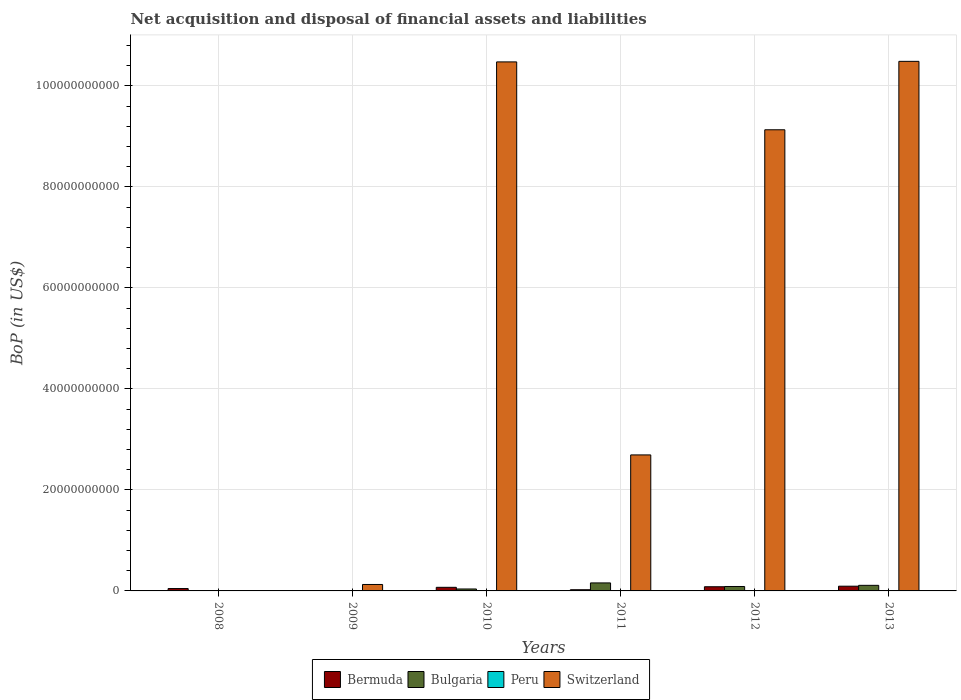How many different coloured bars are there?
Your answer should be very brief. 3. Are the number of bars per tick equal to the number of legend labels?
Your response must be concise. No. How many bars are there on the 2nd tick from the right?
Your answer should be compact. 3. What is the label of the 3rd group of bars from the left?
Keep it short and to the point. 2010. In how many cases, is the number of bars for a given year not equal to the number of legend labels?
Keep it short and to the point. 6. What is the Balance of Payments in Bulgaria in 2008?
Offer a very short reply. 0. Across all years, what is the maximum Balance of Payments in Bermuda?
Provide a succinct answer. 9.35e+08. In which year was the Balance of Payments in Switzerland maximum?
Offer a very short reply. 2013. What is the total Balance of Payments in Bulgaria in the graph?
Provide a succinct answer. 3.96e+09. What is the difference between the Balance of Payments in Bulgaria in 2012 and that in 2013?
Ensure brevity in your answer.  -2.30e+08. What is the difference between the Balance of Payments in Peru in 2008 and the Balance of Payments in Switzerland in 2011?
Offer a terse response. -2.69e+1. What is the average Balance of Payments in Bermuda per year?
Provide a short and direct response. 5.31e+08. In the year 2012, what is the difference between the Balance of Payments in Bulgaria and Balance of Payments in Bermuda?
Provide a short and direct response. 4.86e+07. Is the difference between the Balance of Payments in Bulgaria in 2011 and 2013 greater than the difference between the Balance of Payments in Bermuda in 2011 and 2013?
Offer a very short reply. Yes. What is the difference between the highest and the second highest Balance of Payments in Bermuda?
Your answer should be compact. 1.07e+08. What is the difference between the highest and the lowest Balance of Payments in Bulgaria?
Keep it short and to the point. 1.59e+09. In how many years, is the Balance of Payments in Peru greater than the average Balance of Payments in Peru taken over all years?
Give a very brief answer. 0. Are all the bars in the graph horizontal?
Provide a short and direct response. No. What is the difference between two consecutive major ticks on the Y-axis?
Provide a succinct answer. 2.00e+1. Does the graph contain any zero values?
Give a very brief answer. Yes. Does the graph contain grids?
Keep it short and to the point. Yes. Where does the legend appear in the graph?
Your answer should be compact. Bottom center. What is the title of the graph?
Keep it short and to the point. Net acquisition and disposal of financial assets and liabilities. Does "Argentina" appear as one of the legend labels in the graph?
Give a very brief answer. No. What is the label or title of the Y-axis?
Ensure brevity in your answer.  BoP (in US$). What is the BoP (in US$) in Bermuda in 2008?
Your answer should be compact. 4.69e+08. What is the BoP (in US$) in Peru in 2008?
Provide a short and direct response. 0. What is the BoP (in US$) in Bermuda in 2009?
Your answer should be compact. 0. What is the BoP (in US$) of Peru in 2009?
Your answer should be very brief. 0. What is the BoP (in US$) of Switzerland in 2009?
Make the answer very short. 1.28e+09. What is the BoP (in US$) in Bermuda in 2010?
Your answer should be compact. 7.14e+08. What is the BoP (in US$) in Bulgaria in 2010?
Give a very brief answer. 3.84e+08. What is the BoP (in US$) of Switzerland in 2010?
Provide a short and direct response. 1.05e+11. What is the BoP (in US$) in Bermuda in 2011?
Give a very brief answer. 2.37e+08. What is the BoP (in US$) of Bulgaria in 2011?
Give a very brief answer. 1.59e+09. What is the BoP (in US$) in Peru in 2011?
Keep it short and to the point. 0. What is the BoP (in US$) of Switzerland in 2011?
Provide a succinct answer. 2.69e+1. What is the BoP (in US$) in Bermuda in 2012?
Offer a very short reply. 8.28e+08. What is the BoP (in US$) in Bulgaria in 2012?
Keep it short and to the point. 8.77e+08. What is the BoP (in US$) of Switzerland in 2012?
Your answer should be compact. 9.13e+1. What is the BoP (in US$) in Bermuda in 2013?
Give a very brief answer. 9.35e+08. What is the BoP (in US$) of Bulgaria in 2013?
Make the answer very short. 1.11e+09. What is the BoP (in US$) of Switzerland in 2013?
Make the answer very short. 1.05e+11. Across all years, what is the maximum BoP (in US$) in Bermuda?
Ensure brevity in your answer.  9.35e+08. Across all years, what is the maximum BoP (in US$) in Bulgaria?
Your response must be concise. 1.59e+09. Across all years, what is the maximum BoP (in US$) in Switzerland?
Make the answer very short. 1.05e+11. Across all years, what is the minimum BoP (in US$) of Bermuda?
Your answer should be compact. 0. What is the total BoP (in US$) of Bermuda in the graph?
Make the answer very short. 3.18e+09. What is the total BoP (in US$) of Bulgaria in the graph?
Your answer should be very brief. 3.96e+09. What is the total BoP (in US$) in Peru in the graph?
Offer a terse response. 0. What is the total BoP (in US$) of Switzerland in the graph?
Ensure brevity in your answer.  3.29e+11. What is the difference between the BoP (in US$) of Bermuda in 2008 and that in 2010?
Give a very brief answer. -2.45e+08. What is the difference between the BoP (in US$) of Bermuda in 2008 and that in 2011?
Your answer should be very brief. 2.32e+08. What is the difference between the BoP (in US$) in Bermuda in 2008 and that in 2012?
Keep it short and to the point. -3.59e+08. What is the difference between the BoP (in US$) of Bermuda in 2008 and that in 2013?
Your answer should be compact. -4.66e+08. What is the difference between the BoP (in US$) of Switzerland in 2009 and that in 2010?
Provide a short and direct response. -1.03e+11. What is the difference between the BoP (in US$) of Switzerland in 2009 and that in 2011?
Provide a short and direct response. -2.57e+1. What is the difference between the BoP (in US$) of Switzerland in 2009 and that in 2012?
Ensure brevity in your answer.  -9.00e+1. What is the difference between the BoP (in US$) of Switzerland in 2009 and that in 2013?
Provide a short and direct response. -1.04e+11. What is the difference between the BoP (in US$) in Bermuda in 2010 and that in 2011?
Make the answer very short. 4.77e+08. What is the difference between the BoP (in US$) in Bulgaria in 2010 and that in 2011?
Your response must be concise. -1.20e+09. What is the difference between the BoP (in US$) in Switzerland in 2010 and that in 2011?
Provide a succinct answer. 7.78e+1. What is the difference between the BoP (in US$) of Bermuda in 2010 and that in 2012?
Provide a short and direct response. -1.14e+08. What is the difference between the BoP (in US$) of Bulgaria in 2010 and that in 2012?
Make the answer very short. -4.93e+08. What is the difference between the BoP (in US$) of Switzerland in 2010 and that in 2012?
Keep it short and to the point. 1.34e+1. What is the difference between the BoP (in US$) in Bermuda in 2010 and that in 2013?
Offer a terse response. -2.21e+08. What is the difference between the BoP (in US$) of Bulgaria in 2010 and that in 2013?
Keep it short and to the point. -7.23e+08. What is the difference between the BoP (in US$) of Switzerland in 2010 and that in 2013?
Keep it short and to the point. -1.09e+08. What is the difference between the BoP (in US$) of Bermuda in 2011 and that in 2012?
Your answer should be compact. -5.91e+08. What is the difference between the BoP (in US$) in Bulgaria in 2011 and that in 2012?
Provide a short and direct response. 7.10e+08. What is the difference between the BoP (in US$) of Switzerland in 2011 and that in 2012?
Offer a terse response. -6.44e+1. What is the difference between the BoP (in US$) of Bermuda in 2011 and that in 2013?
Ensure brevity in your answer.  -6.98e+08. What is the difference between the BoP (in US$) in Bulgaria in 2011 and that in 2013?
Offer a very short reply. 4.80e+08. What is the difference between the BoP (in US$) of Switzerland in 2011 and that in 2013?
Your answer should be compact. -7.79e+1. What is the difference between the BoP (in US$) in Bermuda in 2012 and that in 2013?
Make the answer very short. -1.07e+08. What is the difference between the BoP (in US$) in Bulgaria in 2012 and that in 2013?
Provide a succinct answer. -2.30e+08. What is the difference between the BoP (in US$) of Switzerland in 2012 and that in 2013?
Keep it short and to the point. -1.35e+1. What is the difference between the BoP (in US$) in Bermuda in 2008 and the BoP (in US$) in Switzerland in 2009?
Your answer should be compact. -8.06e+08. What is the difference between the BoP (in US$) in Bermuda in 2008 and the BoP (in US$) in Bulgaria in 2010?
Make the answer very short. 8.53e+07. What is the difference between the BoP (in US$) of Bermuda in 2008 and the BoP (in US$) of Switzerland in 2010?
Ensure brevity in your answer.  -1.04e+11. What is the difference between the BoP (in US$) of Bermuda in 2008 and the BoP (in US$) of Bulgaria in 2011?
Give a very brief answer. -1.12e+09. What is the difference between the BoP (in US$) of Bermuda in 2008 and the BoP (in US$) of Switzerland in 2011?
Your answer should be very brief. -2.65e+1. What is the difference between the BoP (in US$) in Bermuda in 2008 and the BoP (in US$) in Bulgaria in 2012?
Provide a succinct answer. -4.07e+08. What is the difference between the BoP (in US$) in Bermuda in 2008 and the BoP (in US$) in Switzerland in 2012?
Offer a very short reply. -9.09e+1. What is the difference between the BoP (in US$) of Bermuda in 2008 and the BoP (in US$) of Bulgaria in 2013?
Provide a short and direct response. -6.37e+08. What is the difference between the BoP (in US$) of Bermuda in 2008 and the BoP (in US$) of Switzerland in 2013?
Make the answer very short. -1.04e+11. What is the difference between the BoP (in US$) in Bermuda in 2010 and the BoP (in US$) in Bulgaria in 2011?
Provide a short and direct response. -8.73e+08. What is the difference between the BoP (in US$) in Bermuda in 2010 and the BoP (in US$) in Switzerland in 2011?
Offer a terse response. -2.62e+1. What is the difference between the BoP (in US$) in Bulgaria in 2010 and the BoP (in US$) in Switzerland in 2011?
Give a very brief answer. -2.65e+1. What is the difference between the BoP (in US$) in Bermuda in 2010 and the BoP (in US$) in Bulgaria in 2012?
Your answer should be very brief. -1.63e+08. What is the difference between the BoP (in US$) in Bermuda in 2010 and the BoP (in US$) in Switzerland in 2012?
Offer a terse response. -9.06e+1. What is the difference between the BoP (in US$) in Bulgaria in 2010 and the BoP (in US$) in Switzerland in 2012?
Keep it short and to the point. -9.09e+1. What is the difference between the BoP (in US$) of Bermuda in 2010 and the BoP (in US$) of Bulgaria in 2013?
Your response must be concise. -3.93e+08. What is the difference between the BoP (in US$) in Bermuda in 2010 and the BoP (in US$) in Switzerland in 2013?
Offer a terse response. -1.04e+11. What is the difference between the BoP (in US$) in Bulgaria in 2010 and the BoP (in US$) in Switzerland in 2013?
Give a very brief answer. -1.04e+11. What is the difference between the BoP (in US$) in Bermuda in 2011 and the BoP (in US$) in Bulgaria in 2012?
Your response must be concise. -6.39e+08. What is the difference between the BoP (in US$) of Bermuda in 2011 and the BoP (in US$) of Switzerland in 2012?
Provide a succinct answer. -9.11e+1. What is the difference between the BoP (in US$) of Bulgaria in 2011 and the BoP (in US$) of Switzerland in 2012?
Provide a short and direct response. -8.97e+1. What is the difference between the BoP (in US$) of Bermuda in 2011 and the BoP (in US$) of Bulgaria in 2013?
Provide a short and direct response. -8.69e+08. What is the difference between the BoP (in US$) in Bermuda in 2011 and the BoP (in US$) in Switzerland in 2013?
Make the answer very short. -1.05e+11. What is the difference between the BoP (in US$) in Bulgaria in 2011 and the BoP (in US$) in Switzerland in 2013?
Your answer should be very brief. -1.03e+11. What is the difference between the BoP (in US$) in Bermuda in 2012 and the BoP (in US$) in Bulgaria in 2013?
Offer a terse response. -2.79e+08. What is the difference between the BoP (in US$) in Bermuda in 2012 and the BoP (in US$) in Switzerland in 2013?
Keep it short and to the point. -1.04e+11. What is the difference between the BoP (in US$) of Bulgaria in 2012 and the BoP (in US$) of Switzerland in 2013?
Give a very brief answer. -1.04e+11. What is the average BoP (in US$) of Bermuda per year?
Offer a very short reply. 5.31e+08. What is the average BoP (in US$) in Bulgaria per year?
Make the answer very short. 6.59e+08. What is the average BoP (in US$) in Switzerland per year?
Provide a succinct answer. 5.49e+1. In the year 2010, what is the difference between the BoP (in US$) in Bermuda and BoP (in US$) in Bulgaria?
Your answer should be very brief. 3.30e+08. In the year 2010, what is the difference between the BoP (in US$) of Bermuda and BoP (in US$) of Switzerland?
Offer a terse response. -1.04e+11. In the year 2010, what is the difference between the BoP (in US$) in Bulgaria and BoP (in US$) in Switzerland?
Give a very brief answer. -1.04e+11. In the year 2011, what is the difference between the BoP (in US$) in Bermuda and BoP (in US$) in Bulgaria?
Keep it short and to the point. -1.35e+09. In the year 2011, what is the difference between the BoP (in US$) in Bermuda and BoP (in US$) in Switzerland?
Your answer should be very brief. -2.67e+1. In the year 2011, what is the difference between the BoP (in US$) of Bulgaria and BoP (in US$) of Switzerland?
Your response must be concise. -2.53e+1. In the year 2012, what is the difference between the BoP (in US$) in Bermuda and BoP (in US$) in Bulgaria?
Your response must be concise. -4.86e+07. In the year 2012, what is the difference between the BoP (in US$) of Bermuda and BoP (in US$) of Switzerland?
Offer a very short reply. -9.05e+1. In the year 2012, what is the difference between the BoP (in US$) in Bulgaria and BoP (in US$) in Switzerland?
Make the answer very short. -9.04e+1. In the year 2013, what is the difference between the BoP (in US$) in Bermuda and BoP (in US$) in Bulgaria?
Provide a succinct answer. -1.72e+08. In the year 2013, what is the difference between the BoP (in US$) in Bermuda and BoP (in US$) in Switzerland?
Provide a short and direct response. -1.04e+11. In the year 2013, what is the difference between the BoP (in US$) in Bulgaria and BoP (in US$) in Switzerland?
Provide a short and direct response. -1.04e+11. What is the ratio of the BoP (in US$) in Bermuda in 2008 to that in 2010?
Ensure brevity in your answer.  0.66. What is the ratio of the BoP (in US$) of Bermuda in 2008 to that in 2011?
Provide a succinct answer. 1.98. What is the ratio of the BoP (in US$) of Bermuda in 2008 to that in 2012?
Give a very brief answer. 0.57. What is the ratio of the BoP (in US$) in Bermuda in 2008 to that in 2013?
Your answer should be compact. 0.5. What is the ratio of the BoP (in US$) of Switzerland in 2009 to that in 2010?
Offer a terse response. 0.01. What is the ratio of the BoP (in US$) in Switzerland in 2009 to that in 2011?
Your response must be concise. 0.05. What is the ratio of the BoP (in US$) in Switzerland in 2009 to that in 2012?
Give a very brief answer. 0.01. What is the ratio of the BoP (in US$) in Switzerland in 2009 to that in 2013?
Keep it short and to the point. 0.01. What is the ratio of the BoP (in US$) in Bermuda in 2010 to that in 2011?
Keep it short and to the point. 3.01. What is the ratio of the BoP (in US$) in Bulgaria in 2010 to that in 2011?
Ensure brevity in your answer.  0.24. What is the ratio of the BoP (in US$) of Switzerland in 2010 to that in 2011?
Ensure brevity in your answer.  3.89. What is the ratio of the BoP (in US$) of Bermuda in 2010 to that in 2012?
Your answer should be very brief. 0.86. What is the ratio of the BoP (in US$) in Bulgaria in 2010 to that in 2012?
Provide a short and direct response. 0.44. What is the ratio of the BoP (in US$) in Switzerland in 2010 to that in 2012?
Provide a short and direct response. 1.15. What is the ratio of the BoP (in US$) of Bermuda in 2010 to that in 2013?
Provide a short and direct response. 0.76. What is the ratio of the BoP (in US$) of Bulgaria in 2010 to that in 2013?
Provide a short and direct response. 0.35. What is the ratio of the BoP (in US$) of Switzerland in 2010 to that in 2013?
Give a very brief answer. 1. What is the ratio of the BoP (in US$) of Bermuda in 2011 to that in 2012?
Make the answer very short. 0.29. What is the ratio of the BoP (in US$) in Bulgaria in 2011 to that in 2012?
Keep it short and to the point. 1.81. What is the ratio of the BoP (in US$) in Switzerland in 2011 to that in 2012?
Make the answer very short. 0.29. What is the ratio of the BoP (in US$) in Bermuda in 2011 to that in 2013?
Keep it short and to the point. 0.25. What is the ratio of the BoP (in US$) of Bulgaria in 2011 to that in 2013?
Offer a terse response. 1.43. What is the ratio of the BoP (in US$) in Switzerland in 2011 to that in 2013?
Keep it short and to the point. 0.26. What is the ratio of the BoP (in US$) of Bermuda in 2012 to that in 2013?
Your response must be concise. 0.89. What is the ratio of the BoP (in US$) of Bulgaria in 2012 to that in 2013?
Your answer should be compact. 0.79. What is the ratio of the BoP (in US$) of Switzerland in 2012 to that in 2013?
Make the answer very short. 0.87. What is the difference between the highest and the second highest BoP (in US$) in Bermuda?
Make the answer very short. 1.07e+08. What is the difference between the highest and the second highest BoP (in US$) in Bulgaria?
Offer a very short reply. 4.80e+08. What is the difference between the highest and the second highest BoP (in US$) in Switzerland?
Offer a very short reply. 1.09e+08. What is the difference between the highest and the lowest BoP (in US$) in Bermuda?
Your answer should be compact. 9.35e+08. What is the difference between the highest and the lowest BoP (in US$) in Bulgaria?
Your answer should be very brief. 1.59e+09. What is the difference between the highest and the lowest BoP (in US$) in Switzerland?
Your answer should be compact. 1.05e+11. 